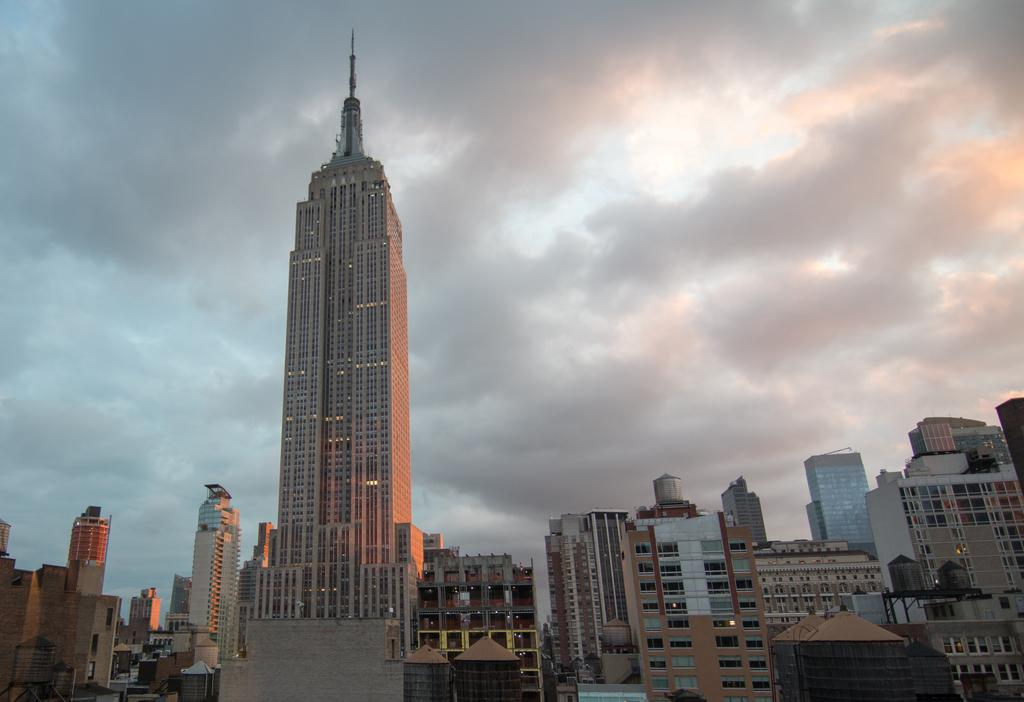What type of structures can be seen in the image? There are buildings and skyscrapers in the image. What is visible at the top of the image? The sky is visible at the top of the image. What company is responsible for the construction of the buildings in the image? The provided facts do not mention any specific companies, so it is impossible to determine which company is responsible for the construction of the buildings in the image. How many children are playing in the image? There are no children present in the image. 